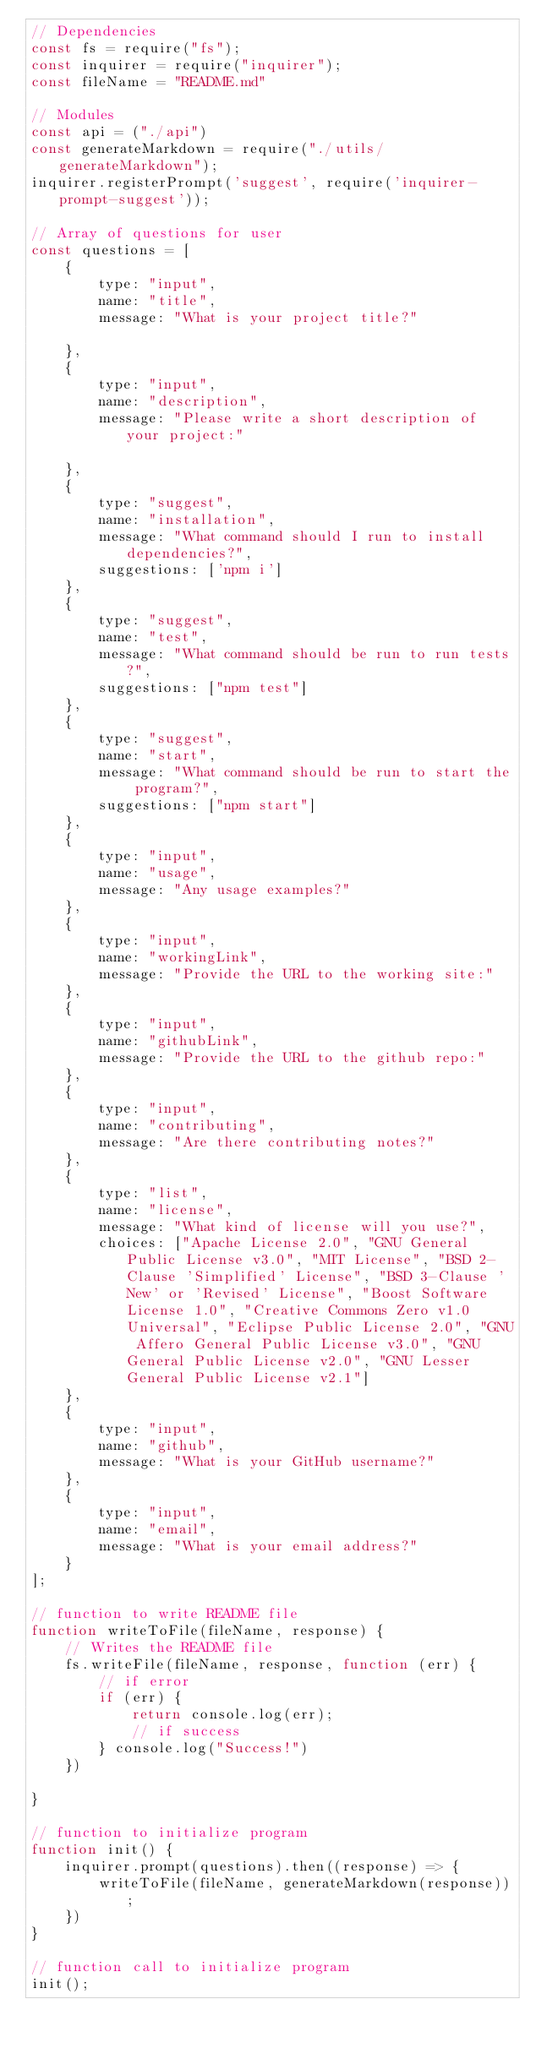Convert code to text. <code><loc_0><loc_0><loc_500><loc_500><_JavaScript_>// Dependencies
const fs = require("fs");
const inquirer = require("inquirer");
const fileName = "README.md"

// Modules
const api = ("./api")
const generateMarkdown = require("./utils/generateMarkdown");
inquirer.registerPrompt('suggest', require('inquirer-prompt-suggest'));

// Array of questions for user
const questions = [
    {
        type: "input",
        name: "title",
        message: "What is your project title?"

    },
    {
        type: "input",
        name: "description",
        message: "Please write a short description of your project:"

    },
    {
        type: "suggest",
        name: "installation",
        message: "What command should I run to install dependencies?",
        suggestions: ['npm i']
    },
    {
        type: "suggest",
        name: "test",
        message: "What command should be run to run tests?",
        suggestions: ["npm test"]
    },
    {
        type: "suggest",
        name: "start",
        message: "What command should be run to start the program?",
        suggestions: ["npm start"]
    },
    {
        type: "input",
        name: "usage",
        message: "Any usage examples?"
    },
    {
        type: "input",
        name: "workingLink",
        message: "Provide the URL to the working site:"
    },
    {
        type: "input",
        name: "githubLink",
        message: "Provide the URL to the github repo:"
    },
    {
        type: "input",
        name: "contributing",
        message: "Are there contributing notes?"
    },
    {
        type: "list",
        name: "license",
        message: "What kind of license will you use?",
        choices: ["Apache License 2.0", "GNU General Public License v3.0", "MIT License", "BSD 2-Clause 'Simplified' License", "BSD 3-Clause 'New' or 'Revised' License", "Boost Software License 1.0", "Creative Commons Zero v1.0 Universal", "Eclipse Public License 2.0", "GNU Affero General Public License v3.0", "GNU General Public License v2.0", "GNU Lesser General Public License v2.1"]
    },
    {
        type: "input",
        name: "github",
        message: "What is your GitHub username?"
    },
    {
        type: "input",
        name: "email",
        message: "What is your email address?"
    }
];

// function to write README file
function writeToFile(fileName, response) {
    // Writes the README file
    fs.writeFile(fileName, response, function (err) {
        // if error
        if (err) {
            return console.log(err);
            // if success
        } console.log("Success!")
    })

}

// function to initialize program
function init() {
    inquirer.prompt(questions).then((response) => {
        writeToFile(fileName, generateMarkdown(response));
    })
}

// function call to initialize program
init();</code> 